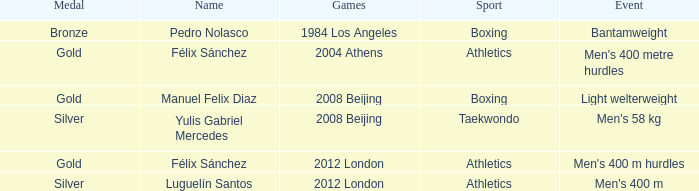Which Name had a Games of 2008 beijing, and a Medal of gold? Manuel Felix Diaz. 